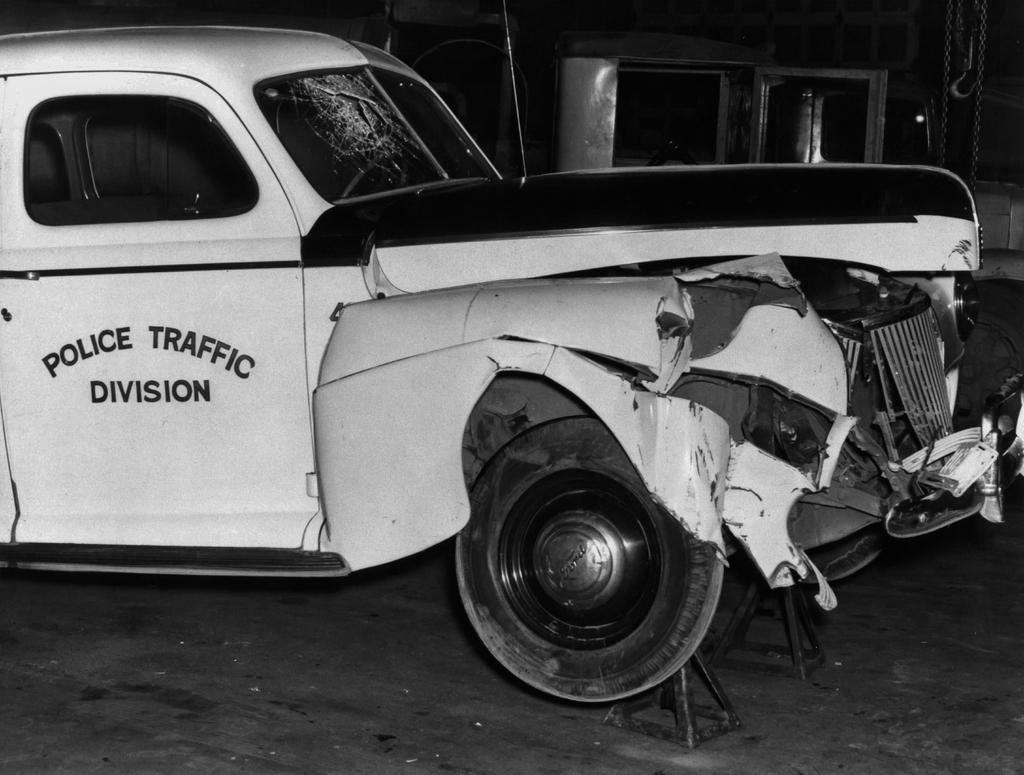What is the main subject of the image? There is a car in the image. Can you describe the condition of the car? The car is damaged. Is there any text or writing on the car? Yes, there is writing on the car. What can be seen in the background of the image? There is a path visible in the image. How would you describe the lighting in the image? The image appears to be in a darker setting. Can you tell me how many baskets are hanging from the car in the image? There are no baskets present in the image; it features a damaged car with writing on it. What type of humor is being displayed by the car in the image? There is no humor displayed by the car in the image; it is simply a damaged car with writing on it. 